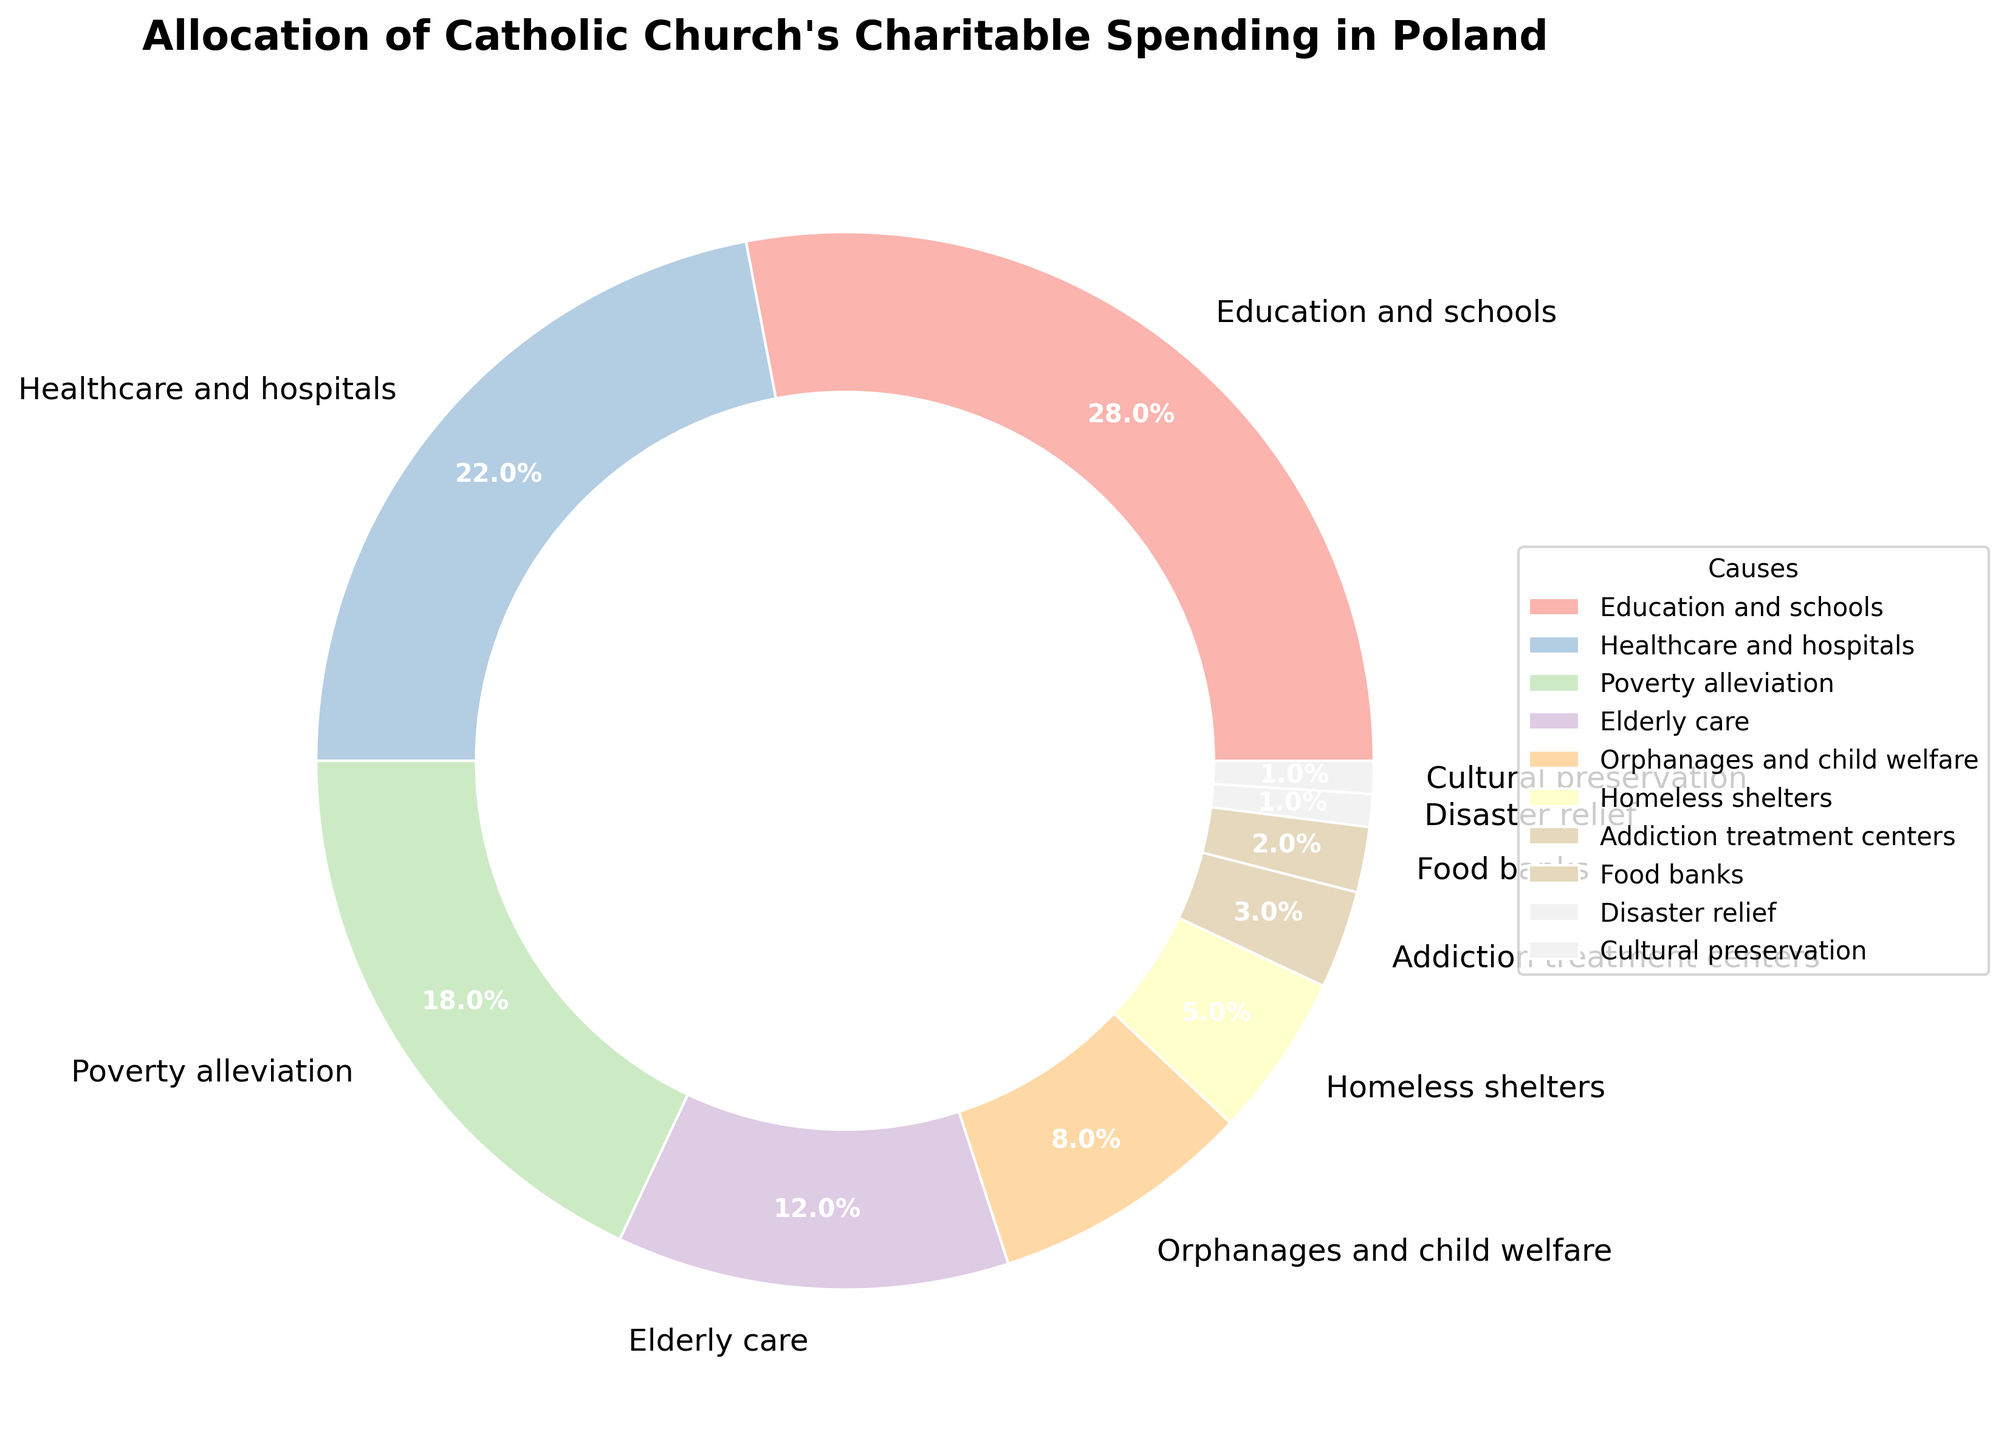What is the most funded cause according to the pie chart? The chart shows that the "Education and schools" segment is the largest.
Answer: Education and schools Which cause has more funding, Healthcare and hospitals or Poverty alleviation? By comparing the sizes of the segments, "Healthcare and hospitals" has 22% while "Poverty alleviation" has 18%.
Answer: Healthcare and hospitals What percentage of the funding goes to Orphanages and child welfare and Homeless shelters combined? The percentages for Orphanages and child welfare (8%) and Homeless shelters (5%) sum up to 8% + 5% = 13%.
Answer: 13% How does the funding for Elderly care compare with that for Addiction treatment centers? "Elderly care" receives 12% of the funds, while "Addiction treatment centers" get 3%. Thus, Elderly care receives more funding.
Answer: Elderly care What is the difference in funding between the top-funded cause and the least-funded cause? "Education and schools" receives 28%, while "Disaster relief" and "Cultural preservation" each receive 1%. The difference is 28% - 1% = 27%.
Answer: 27% Which color segment represents Food banks? The "Food banks" segment is associated with a pastel color from the pie chart. The visual indicates a light pink shade.
Answer: Light pink If funding for Food banks and Disaster relief were doubled, what would their combined funding percentage be? Currently, Food banks have 2% and Disaster relief has 1%. Doubling these figures results in 2% * 2 = 4% and 1% * 2 = 2%, summing to 4% + 2% = 6%.
Answer: 6% Compare the funding allocations for Educational purposes (Education and schools) to Healthcare purposes (Healthcare and hospitals and Addiction treatment centers). Education and schools get 28%. Combining Healthcare and hospitals (22%) and Addiction treatment centers (3%) gives 22% + 3% = 25%. Therefore, Educational purposes receive more.
Answer: Education and schools What fraction (not percentage) of total funding goes to Orphanages and child welfare? The chart shows 8% for Orphanages and child welfare. To convert this to a fraction, use 8/100 which simplifies to 2/25.
Answer: 2/25 